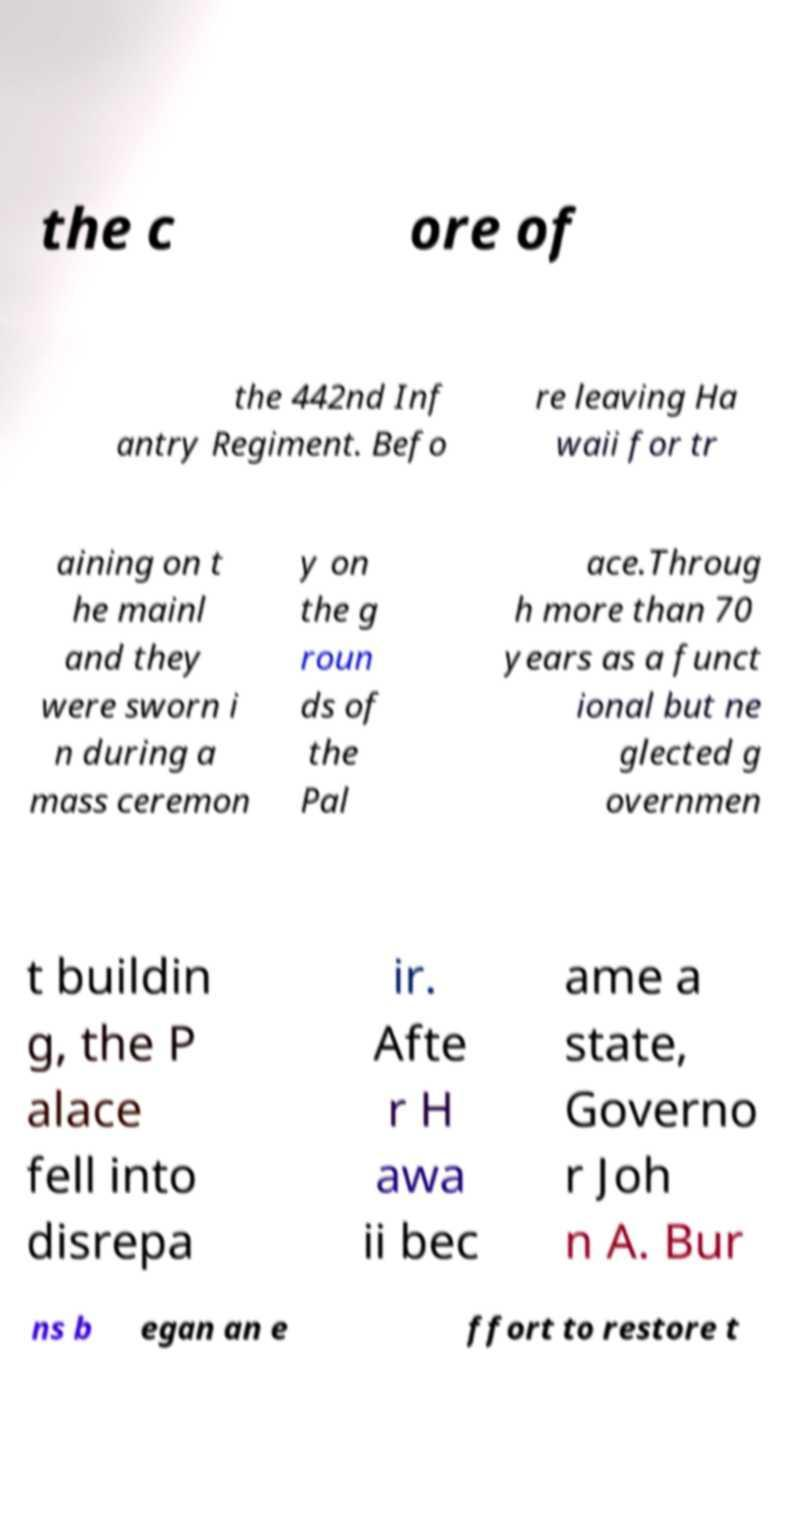Please identify and transcribe the text found in this image. the c ore of the 442nd Inf antry Regiment. Befo re leaving Ha waii for tr aining on t he mainl and they were sworn i n during a mass ceremon y on the g roun ds of the Pal ace.Throug h more than 70 years as a funct ional but ne glected g overnmen t buildin g, the P alace fell into disrepa ir. Afte r H awa ii bec ame a state, Governo r Joh n A. Bur ns b egan an e ffort to restore t 